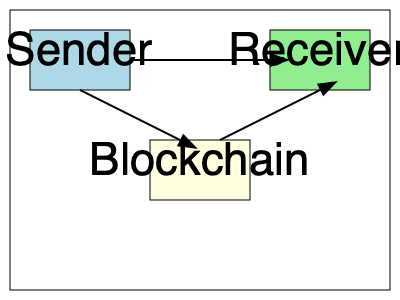In the blockchain transaction flow diagram, what is the correct sequence of steps for a transaction to be completed? To interpret this basic blockchain transaction flow diagram, we need to follow these steps:

1. Identify the key components:
   - Sender (blue box on the left)
   - Receiver (green box on the right)
   - Blockchain (yellow box in the middle)

2. Observe the direction of the arrows:
   - There's an arrow from Sender to Receiver
   - There's an arrow from Sender to Blockchain
   - There's an arrow from Blockchain to Receiver

3. Interpret the flow:
   - The first step is the direct interaction between Sender and Receiver (top arrow)
   - The second step involves the Sender submitting the transaction to the Blockchain
   - The final step is the Blockchain confirming the transaction with the Receiver

4. Conclude the sequence:
   The correct sequence is Sender -> Receiver (initial interaction), then Sender -> Blockchain (transaction submission), and finally Blockchain -> Receiver (transaction confirmation).

This flow represents a typical blockchain transaction where the parties first agree on the transaction, then it's recorded on the blockchain, and finally confirmed with the recipient.
Answer: Sender to Receiver, Sender to Blockchain, Blockchain to Receiver 